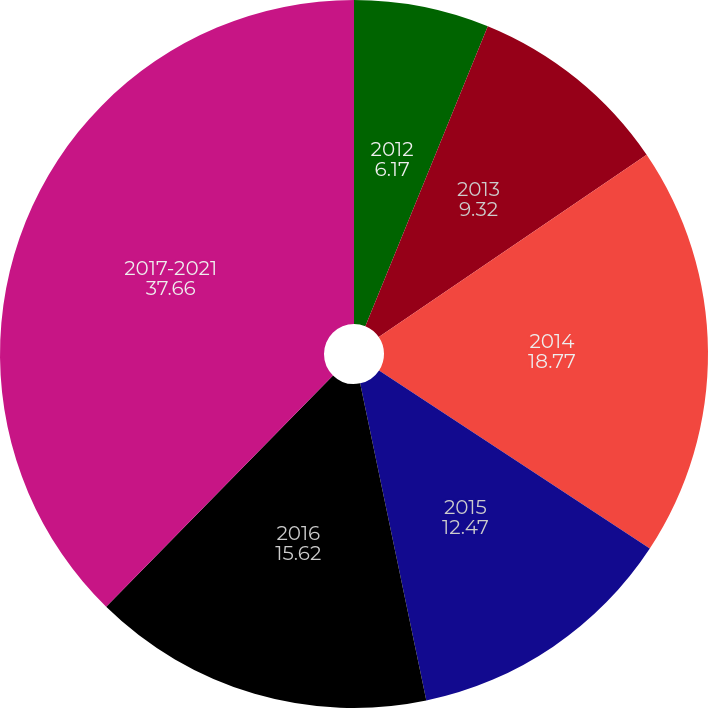Convert chart to OTSL. <chart><loc_0><loc_0><loc_500><loc_500><pie_chart><fcel>2012<fcel>2013<fcel>2014<fcel>2015<fcel>2016<fcel>2017-2021<nl><fcel>6.17%<fcel>9.32%<fcel>18.77%<fcel>12.47%<fcel>15.62%<fcel>37.66%<nl></chart> 